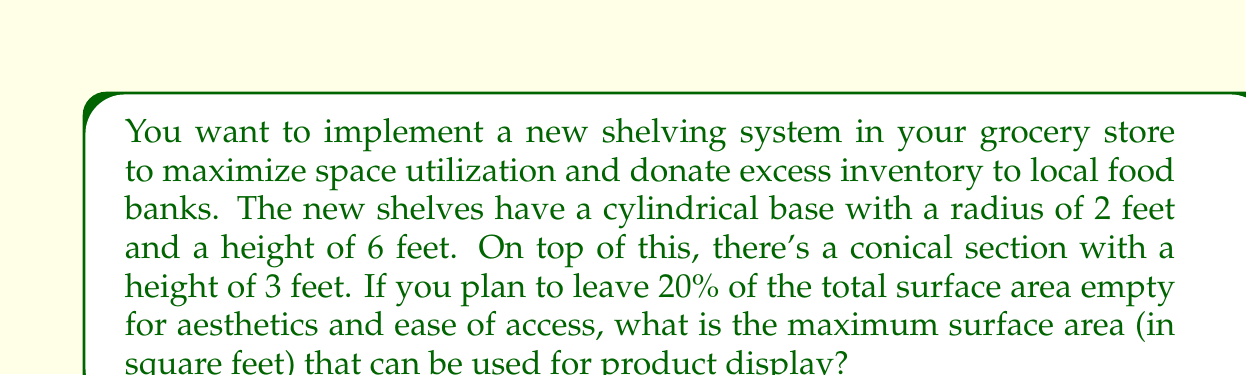Give your solution to this math problem. Let's approach this step-by-step:

1) First, we need to calculate the total surface area of the shelf unit.

2) The shelf consists of two parts: a cylinder and a cone.

3) For the cylinder:
   - Lateral surface area: $A_{cylinder} = 2\pi rh = 2\pi \cdot 2 \cdot 6 = 24\pi$ sq ft
   - Base area: $A_{base} = \pi r^2 = \pi \cdot 2^2 = 4\pi$ sq ft

4) For the cone:
   - Lateral surface area: $A_{cone} = \pi rs = \pi r\sqrt{r^2 + h^2} = 2\pi\sqrt{2^2 + 3^2} = 2\pi\sqrt{13}$ sq ft

5) Total surface area:
   $A_{total} = A_{cylinder} + A_{base} + A_{cone}$
   $A_{total} = 24\pi + 4\pi + 2\pi\sqrt{13} = 28\pi + 2\pi\sqrt{13}$ sq ft

6) We need to leave 20% empty, so we can use 80% of the total area:
   $A_{usable} = 0.8 \cdot (28\pi + 2\pi\sqrt{13})$
   $A_{usable} = 22.4\pi + 1.6\pi\sqrt{13}$ sq ft

7) Simplifying:
   $A_{usable} = 2\pi(11.2 + 0.8\sqrt{13})$ sq ft
Answer: $2\pi(11.2 + 0.8\sqrt{13})$ sq ft 